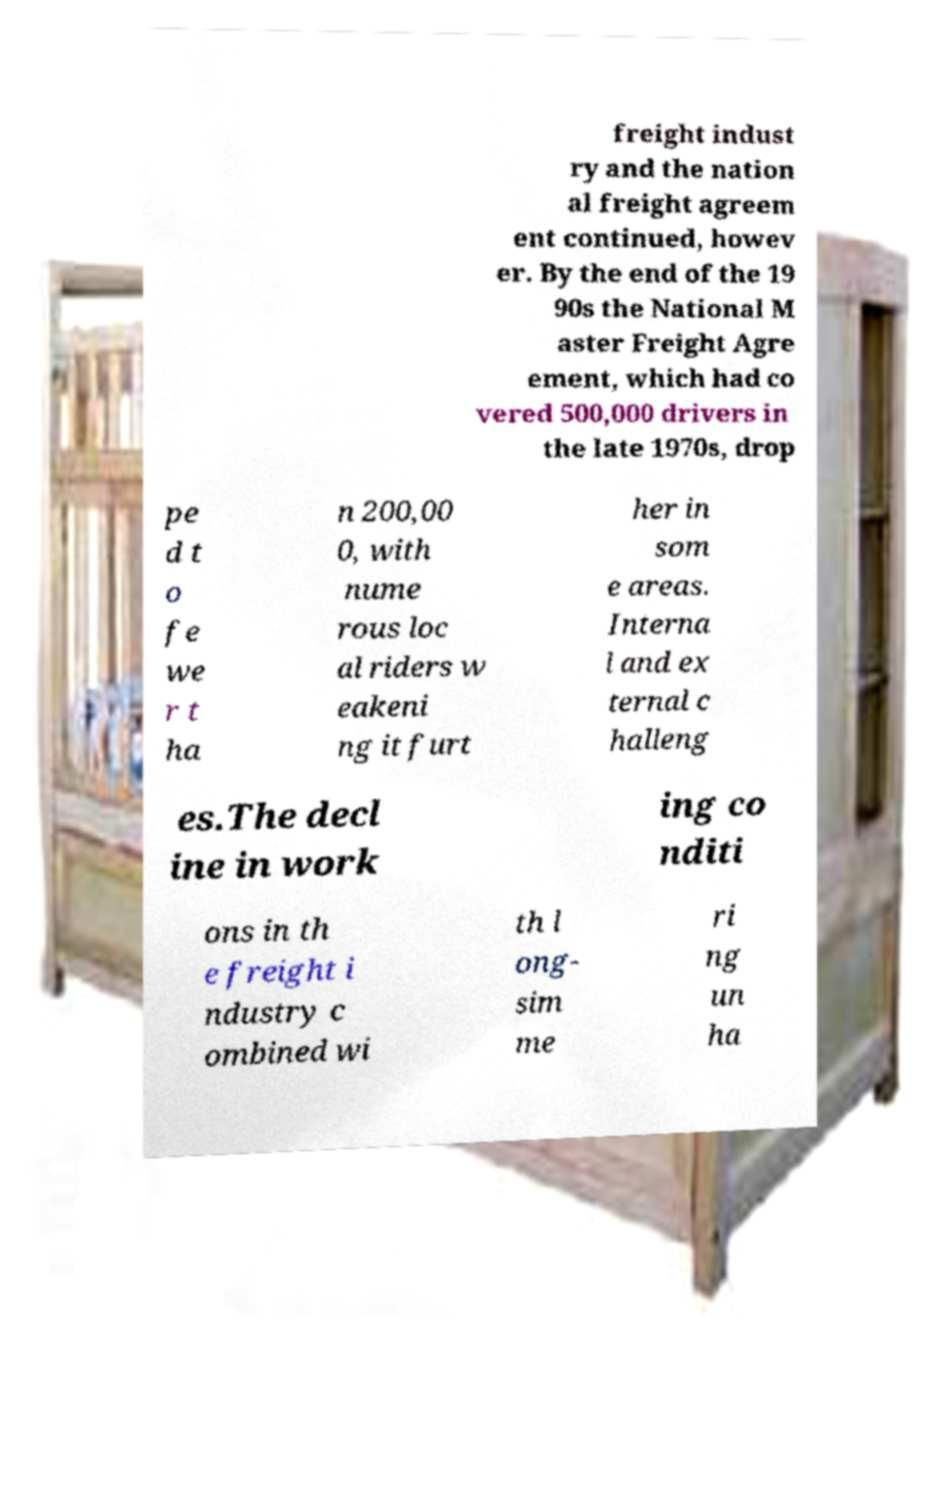What messages or text are displayed in this image? I need them in a readable, typed format. freight indust ry and the nation al freight agreem ent continued, howev er. By the end of the 19 90s the National M aster Freight Agre ement, which had co vered 500,000 drivers in the late 1970s, drop pe d t o fe we r t ha n 200,00 0, with nume rous loc al riders w eakeni ng it furt her in som e areas. Interna l and ex ternal c halleng es.The decl ine in work ing co nditi ons in th e freight i ndustry c ombined wi th l ong- sim me ri ng un ha 